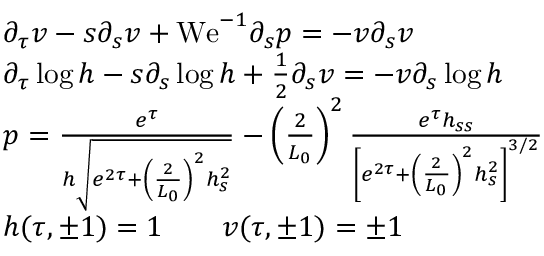<formula> <loc_0><loc_0><loc_500><loc_500>\begin{array} { r l } & { \partial _ { \tau } v - s \partial _ { s } v + W e ^ { - 1 } \partial _ { s } p = - v \partial _ { s } v } \\ & { \partial _ { \tau } \log h - s \partial _ { s } \log h + \frac { 1 } { 2 } \partial _ { s } v = - v \partial _ { s } \log h } \\ & { p = \frac { e ^ { \tau } } { h \sqrt { e ^ { 2 \tau } + \left ( \frac { 2 } { L _ { 0 } } \right ) ^ { 2 } h _ { s } ^ { 2 } } } - \left ( \frac { 2 } { L _ { 0 } } \right ) ^ { 2 } \frac { e ^ { \tau } h _ { s s } } { \left [ e ^ { 2 \tau } + \left ( \frac { 2 } { L _ { 0 } } \right ) ^ { 2 } h _ { s } ^ { 2 } \right ] ^ { 3 / 2 } } } \\ & { h ( \tau , \pm 1 ) = 1 \quad v ( \tau , \pm 1 ) = \pm 1 } \end{array}</formula> 